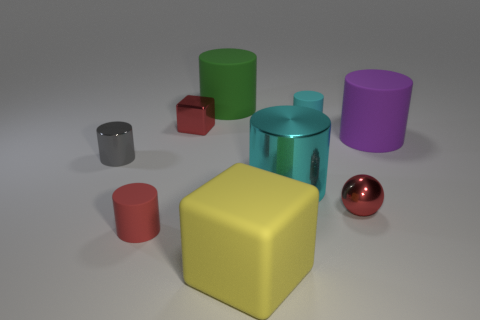There is a matte cylinder that is right of the red metal object that is in front of the shiny block; is there a big cylinder left of it?
Make the answer very short. Yes. What shape is the tiny gray object that is the same material as the large cyan object?
Provide a succinct answer. Cylinder. Are there any other things that are the same shape as the small cyan rubber thing?
Your answer should be compact. Yes. The gray metal object has what shape?
Offer a very short reply. Cylinder. There is a object on the left side of the red cylinder; is its shape the same as the small cyan object?
Provide a short and direct response. Yes. Are there more rubber things that are behind the big yellow object than big metal cylinders that are on the right side of the small cyan matte cylinder?
Offer a terse response. Yes. What number of other objects are the same size as the rubber block?
Make the answer very short. 3. There is a gray thing; is it the same shape as the small matte object behind the small red matte cylinder?
Offer a terse response. Yes. How many metallic objects are spheres or yellow cylinders?
Provide a short and direct response. 1. Is there a shiny object of the same color as the ball?
Give a very brief answer. Yes. 